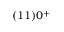<formula> <loc_0><loc_0><loc_500><loc_500>( 1 1 ) 0 ^ { + }</formula> 